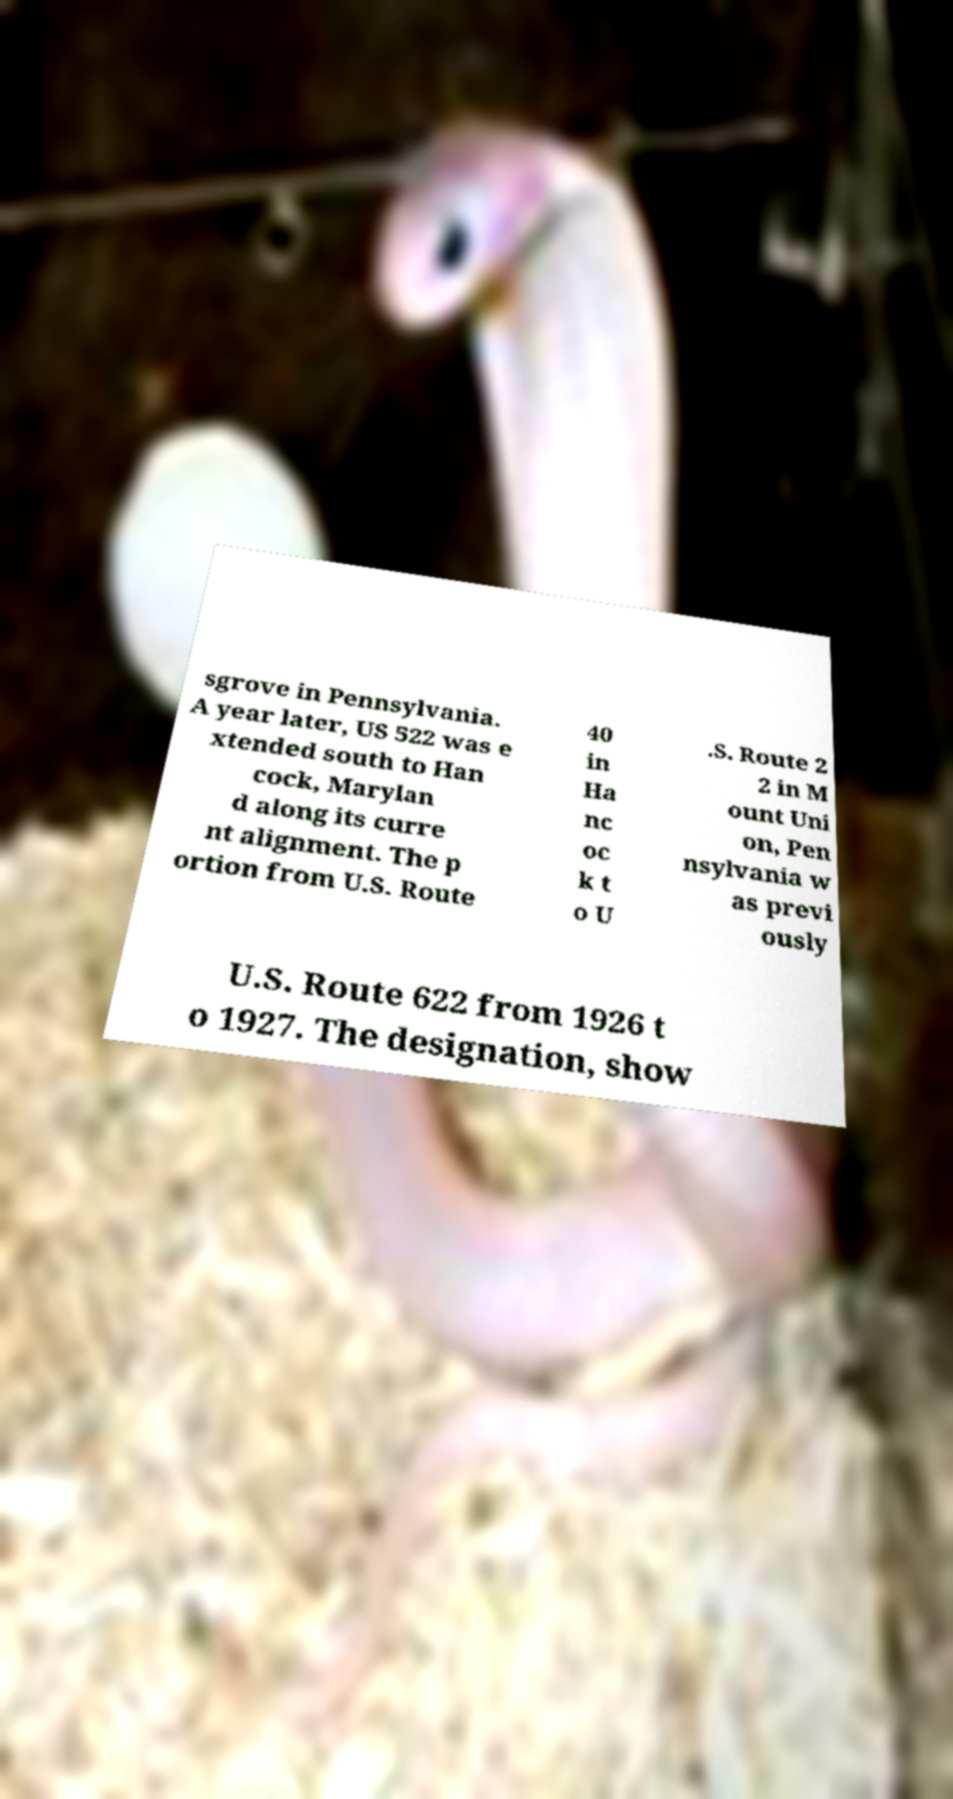Could you assist in decoding the text presented in this image and type it out clearly? sgrove in Pennsylvania. A year later, US 522 was e xtended south to Han cock, Marylan d along its curre nt alignment. The p ortion from U.S. Route 40 in Ha nc oc k t o U .S. Route 2 2 in M ount Uni on, Pen nsylvania w as previ ously U.S. Route 622 from 1926 t o 1927. The designation, show 